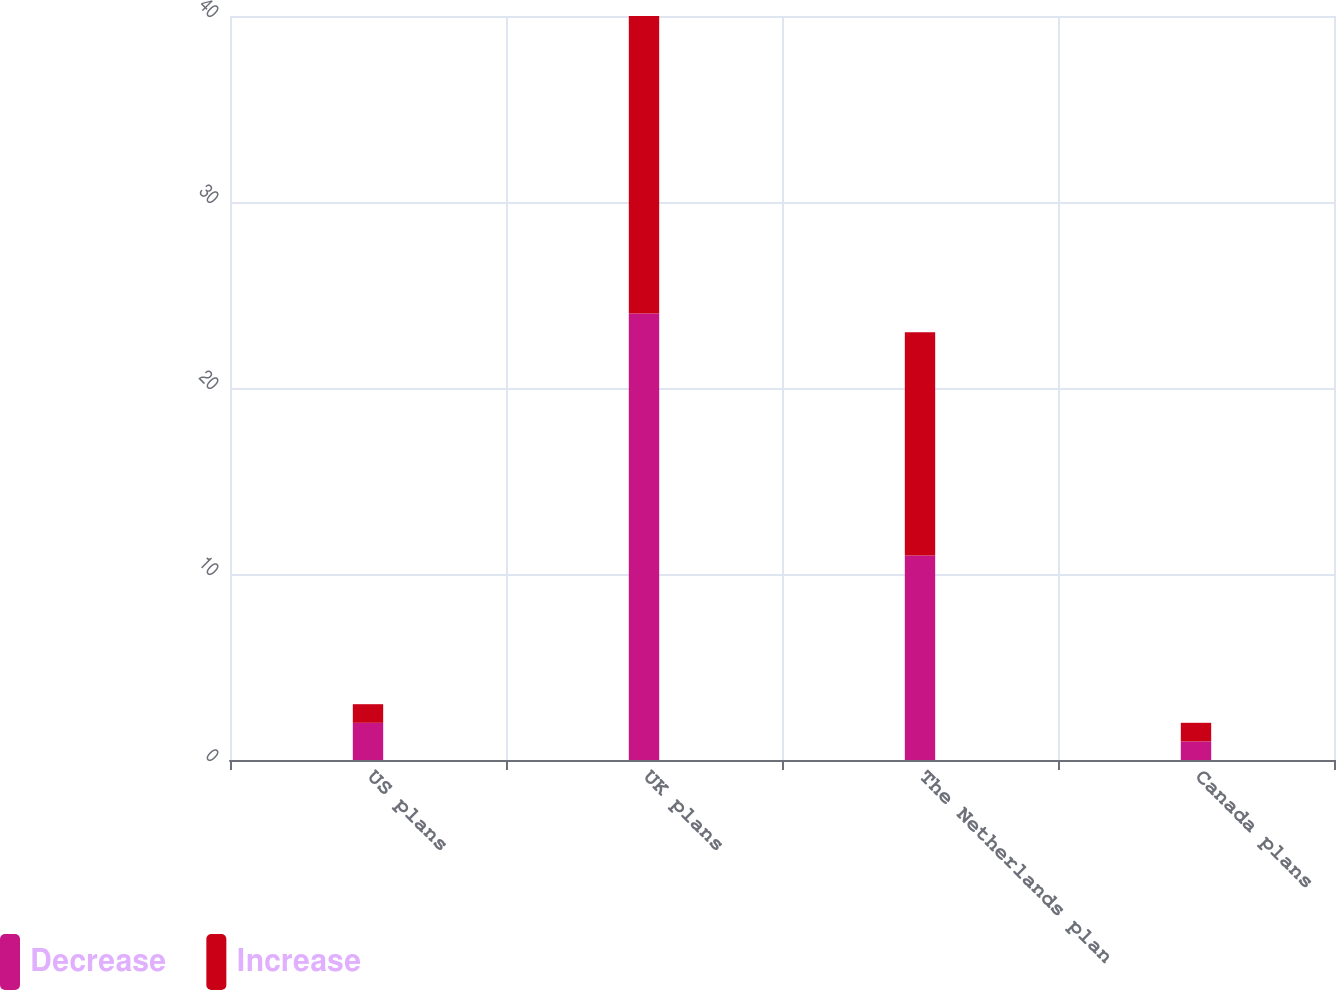Convert chart. <chart><loc_0><loc_0><loc_500><loc_500><stacked_bar_chart><ecel><fcel>US plans<fcel>UK plans<fcel>The Netherlands plan<fcel>Canada plans<nl><fcel>Decrease<fcel>2<fcel>24<fcel>11<fcel>1<nl><fcel>Increase<fcel>1<fcel>16<fcel>12<fcel>1<nl></chart> 